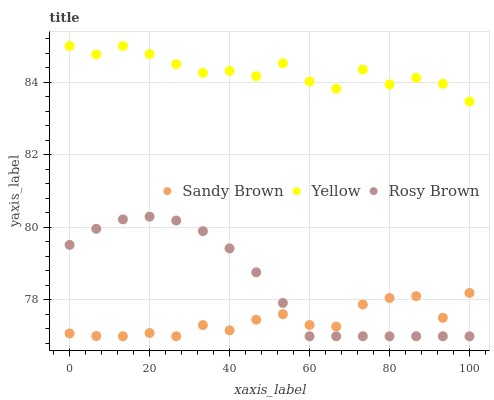Does Sandy Brown have the minimum area under the curve?
Answer yes or no. Yes. Does Yellow have the maximum area under the curve?
Answer yes or no. Yes. Does Yellow have the minimum area under the curve?
Answer yes or no. No. Does Sandy Brown have the maximum area under the curve?
Answer yes or no. No. Is Rosy Brown the smoothest?
Answer yes or no. Yes. Is Yellow the roughest?
Answer yes or no. Yes. Is Sandy Brown the smoothest?
Answer yes or no. No. Is Sandy Brown the roughest?
Answer yes or no. No. Does Rosy Brown have the lowest value?
Answer yes or no. Yes. Does Yellow have the lowest value?
Answer yes or no. No. Does Yellow have the highest value?
Answer yes or no. Yes. Does Sandy Brown have the highest value?
Answer yes or no. No. Is Sandy Brown less than Yellow?
Answer yes or no. Yes. Is Yellow greater than Sandy Brown?
Answer yes or no. Yes. Does Sandy Brown intersect Rosy Brown?
Answer yes or no. Yes. Is Sandy Brown less than Rosy Brown?
Answer yes or no. No. Is Sandy Brown greater than Rosy Brown?
Answer yes or no. No. Does Sandy Brown intersect Yellow?
Answer yes or no. No. 